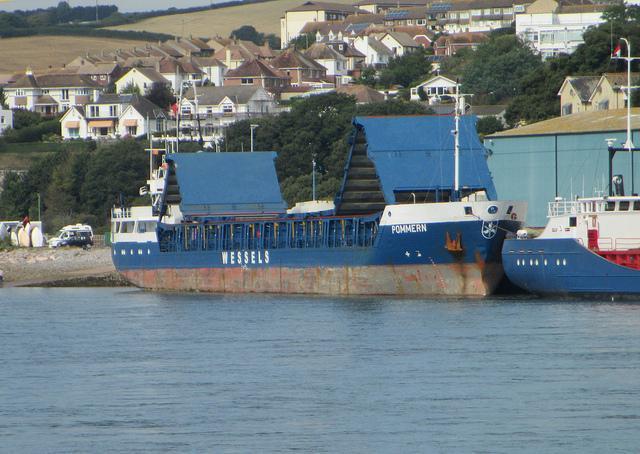How many boats are there?
Give a very brief answer. 2. 